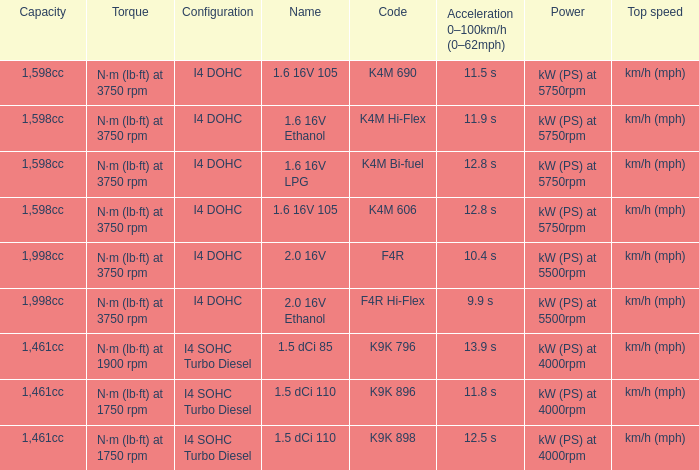What is the code of 1.5 dci 110, which has a capacity of 1,461cc? K9K 896, K9K 898. 